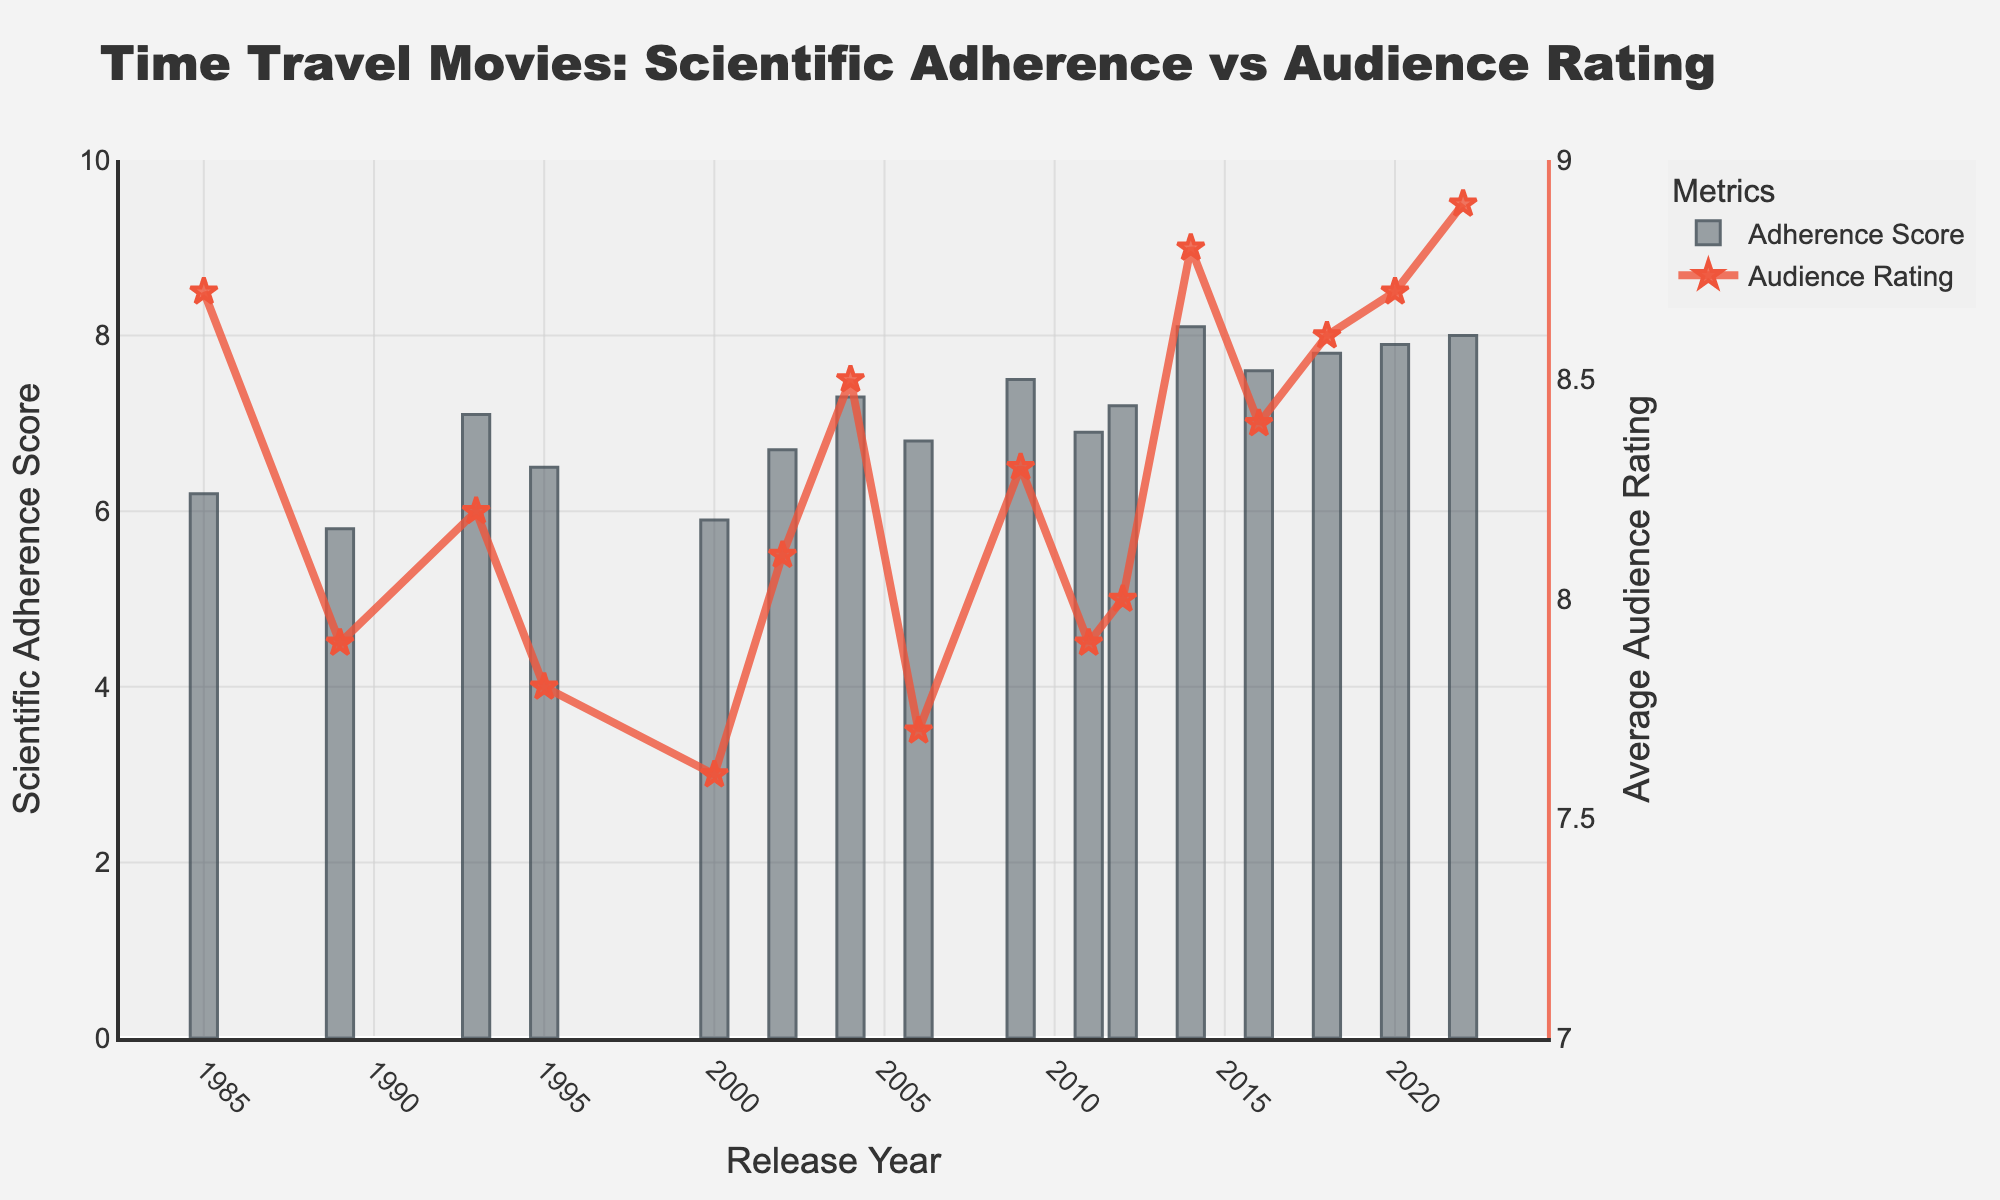What year had the highest Scientific Adherence Score? The year with the highest Scientific Adherence Score can be identified by looking at the tallest bar in the chart. According to the data, the highest score is 8.1, which corresponds to the year 2014.
Answer: 2014 How does the Average Audience Rating in 2022 compare to that in 1985? To compare the ratings, look at the end points of the line graph in 1985 and 2022. In 1985, the average rating is 8.7, and in 2022, it's 8.9. Subtracting these gives 8.9 - 8.7 = 0.2, showing a slight increase.
Answer: 0.2 higher What is the difference in Scientific Adherence Scores between 1989 and 2018? To find the difference, look at the heights of the bars in 1989 and 2018. The score in 1989 is 5.8 and in 2018 is 7.8. Subtract these to get 7.8 - 5.8 = 2.0.
Answer: 2.0 Which year had a lower Adherence Score but higher Average Audience Rating compared to 1995? First, find the values for 1995: Adherence Score is 6.5 and Average Audience Rating is 7.8. Compare this with other years. In 2002, the Adherence Score is 6.7 and Audience Rating is 8.1, so it does not meet the criteria. Checking all other years systematically reveals that 1985 meets the condition with an Adherence Score of 6.2 and a Rating of 8.7.
Answer: 1985 What is the average Scientific Adherence Score from 2000 to 2010? To find the average, sum the Scientific Adherence Scores from 2000 to 2010 and divide by the number of years. Scores are: 5.9, 6.7, 7.3, 6.8, 7.5, 6.9. Sum these (5.9 + 6.7 + 7.3 + 6.8 + 7.5 + 6.9) = 41.1. There are 6 years, so divide 41.1 by 6 = 6.85.
Answer: 6.85 